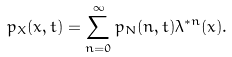<formula> <loc_0><loc_0><loc_500><loc_500>p _ { X } ( x , t ) = \sum _ { n = 0 } ^ { \infty } p _ { N } ( n , t ) \lambda ^ { * n } ( x ) .</formula> 